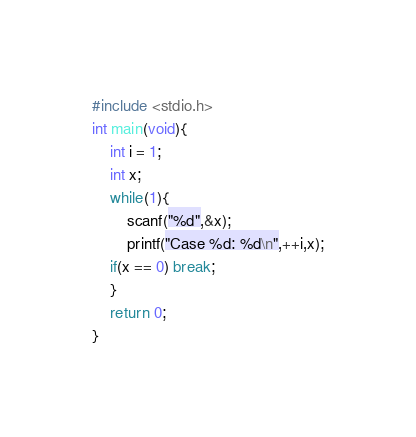Convert code to text. <code><loc_0><loc_0><loc_500><loc_500><_C_>#include <stdio.h>
int main(void){
    int i = 1;
    int x;
    while(1){
        scanf("%d",&x);
        printf("Case %d: %d\n",++i,x);
    if(x == 0) break;
    }
    return 0;
}</code> 